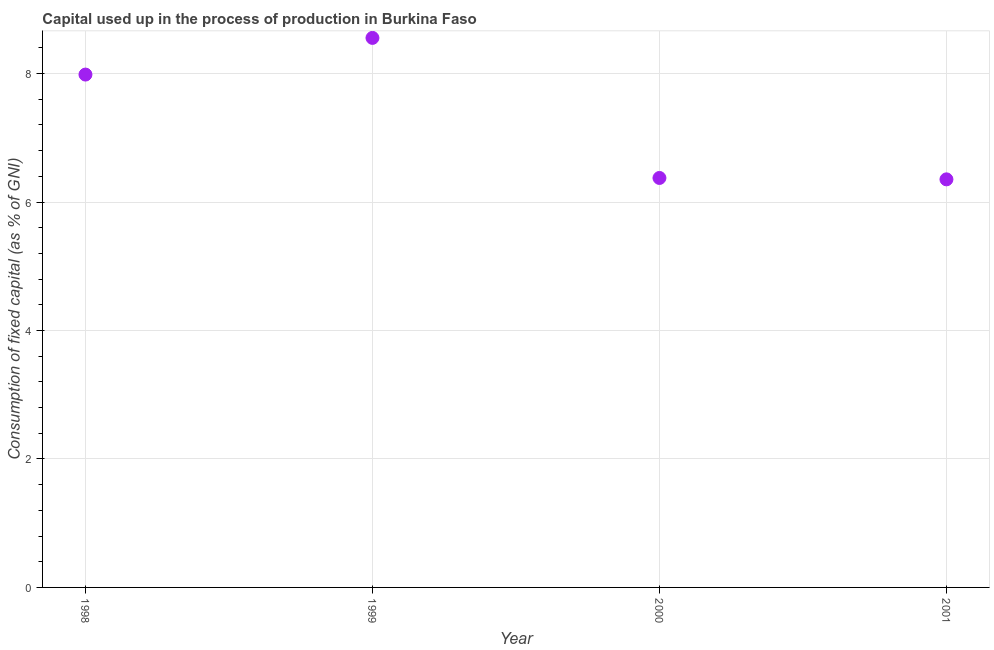What is the consumption of fixed capital in 2000?
Your answer should be compact. 6.37. Across all years, what is the maximum consumption of fixed capital?
Your response must be concise. 8.56. Across all years, what is the minimum consumption of fixed capital?
Keep it short and to the point. 6.35. In which year was the consumption of fixed capital maximum?
Provide a short and direct response. 1999. In which year was the consumption of fixed capital minimum?
Your answer should be compact. 2001. What is the sum of the consumption of fixed capital?
Your response must be concise. 29.27. What is the difference between the consumption of fixed capital in 1999 and 2001?
Your answer should be very brief. 2.2. What is the average consumption of fixed capital per year?
Keep it short and to the point. 7.32. What is the median consumption of fixed capital?
Offer a very short reply. 7.18. Do a majority of the years between 1998 and 1999 (inclusive) have consumption of fixed capital greater than 2.8 %?
Make the answer very short. Yes. What is the ratio of the consumption of fixed capital in 1998 to that in 2000?
Your response must be concise. 1.25. Is the consumption of fixed capital in 1999 less than that in 2000?
Your response must be concise. No. What is the difference between the highest and the second highest consumption of fixed capital?
Ensure brevity in your answer.  0.57. Is the sum of the consumption of fixed capital in 1999 and 2001 greater than the maximum consumption of fixed capital across all years?
Your answer should be compact. Yes. What is the difference between the highest and the lowest consumption of fixed capital?
Your response must be concise. 2.2. In how many years, is the consumption of fixed capital greater than the average consumption of fixed capital taken over all years?
Give a very brief answer. 2. How many dotlines are there?
Your response must be concise. 1. How many years are there in the graph?
Offer a terse response. 4. What is the difference between two consecutive major ticks on the Y-axis?
Provide a short and direct response. 2. Does the graph contain any zero values?
Provide a succinct answer. No. Does the graph contain grids?
Keep it short and to the point. Yes. What is the title of the graph?
Make the answer very short. Capital used up in the process of production in Burkina Faso. What is the label or title of the X-axis?
Offer a very short reply. Year. What is the label or title of the Y-axis?
Provide a succinct answer. Consumption of fixed capital (as % of GNI). What is the Consumption of fixed capital (as % of GNI) in 1998?
Your answer should be compact. 7.98. What is the Consumption of fixed capital (as % of GNI) in 1999?
Provide a succinct answer. 8.56. What is the Consumption of fixed capital (as % of GNI) in 2000?
Give a very brief answer. 6.37. What is the Consumption of fixed capital (as % of GNI) in 2001?
Your response must be concise. 6.35. What is the difference between the Consumption of fixed capital (as % of GNI) in 1998 and 1999?
Keep it short and to the point. -0.57. What is the difference between the Consumption of fixed capital (as % of GNI) in 1998 and 2000?
Your response must be concise. 1.61. What is the difference between the Consumption of fixed capital (as % of GNI) in 1998 and 2001?
Your response must be concise. 1.63. What is the difference between the Consumption of fixed capital (as % of GNI) in 1999 and 2000?
Give a very brief answer. 2.18. What is the difference between the Consumption of fixed capital (as % of GNI) in 1999 and 2001?
Provide a succinct answer. 2.2. What is the difference between the Consumption of fixed capital (as % of GNI) in 2000 and 2001?
Your answer should be compact. 0.02. What is the ratio of the Consumption of fixed capital (as % of GNI) in 1998 to that in 1999?
Make the answer very short. 0.93. What is the ratio of the Consumption of fixed capital (as % of GNI) in 1998 to that in 2000?
Provide a short and direct response. 1.25. What is the ratio of the Consumption of fixed capital (as % of GNI) in 1998 to that in 2001?
Keep it short and to the point. 1.26. What is the ratio of the Consumption of fixed capital (as % of GNI) in 1999 to that in 2000?
Provide a short and direct response. 1.34. What is the ratio of the Consumption of fixed capital (as % of GNI) in 1999 to that in 2001?
Your answer should be compact. 1.35. 